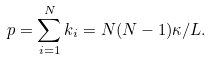Convert formula to latex. <formula><loc_0><loc_0><loc_500><loc_500>p = \sum _ { i = 1 } ^ { N } k _ { i } = N ( N - 1 ) \kappa / L .</formula> 